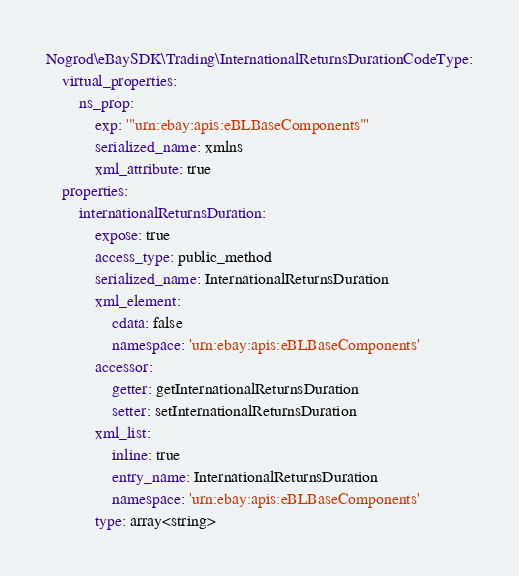<code> <loc_0><loc_0><loc_500><loc_500><_YAML_>Nogrod\eBaySDK\Trading\InternationalReturnsDurationCodeType:
    virtual_properties:
        ns_prop:
            exp: '"urn:ebay:apis:eBLBaseComponents"'
            serialized_name: xmlns
            xml_attribute: true
    properties:
        internationalReturnsDuration:
            expose: true
            access_type: public_method
            serialized_name: InternationalReturnsDuration
            xml_element:
                cdata: false
                namespace: 'urn:ebay:apis:eBLBaseComponents'
            accessor:
                getter: getInternationalReturnsDuration
                setter: setInternationalReturnsDuration
            xml_list:
                inline: true
                entry_name: InternationalReturnsDuration
                namespace: 'urn:ebay:apis:eBLBaseComponents'
            type: array<string>
</code> 